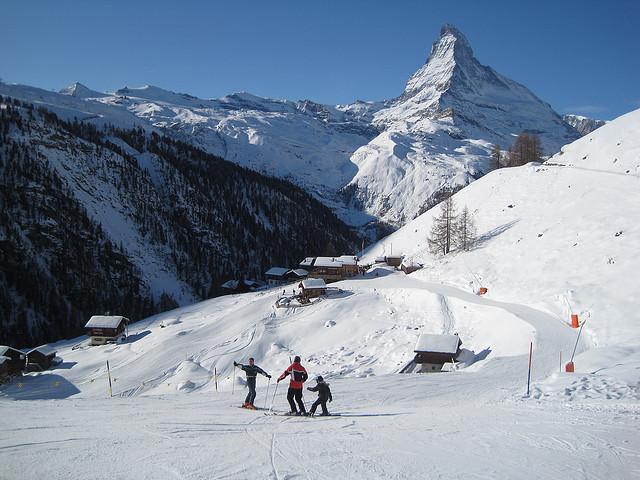How many buses are double-decker buses?
Give a very brief answer. 0. 